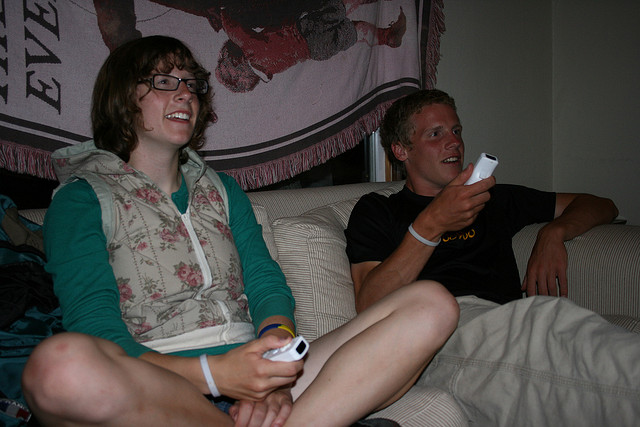Please transcribe the text in this image. EVE 